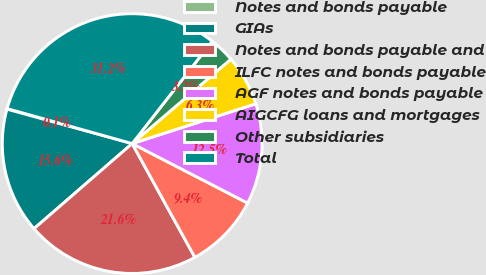<chart> <loc_0><loc_0><loc_500><loc_500><pie_chart><fcel>Notes and bonds payable<fcel>GIAs<fcel>Notes and bonds payable and<fcel>ILFC notes and bonds payable<fcel>AGF notes and bonds payable<fcel>AIGCFG loans and mortgages<fcel>Other subsidiaries<fcel>Total<nl><fcel>0.07%<fcel>15.64%<fcel>21.65%<fcel>9.41%<fcel>12.53%<fcel>6.3%<fcel>3.18%<fcel>31.22%<nl></chart> 